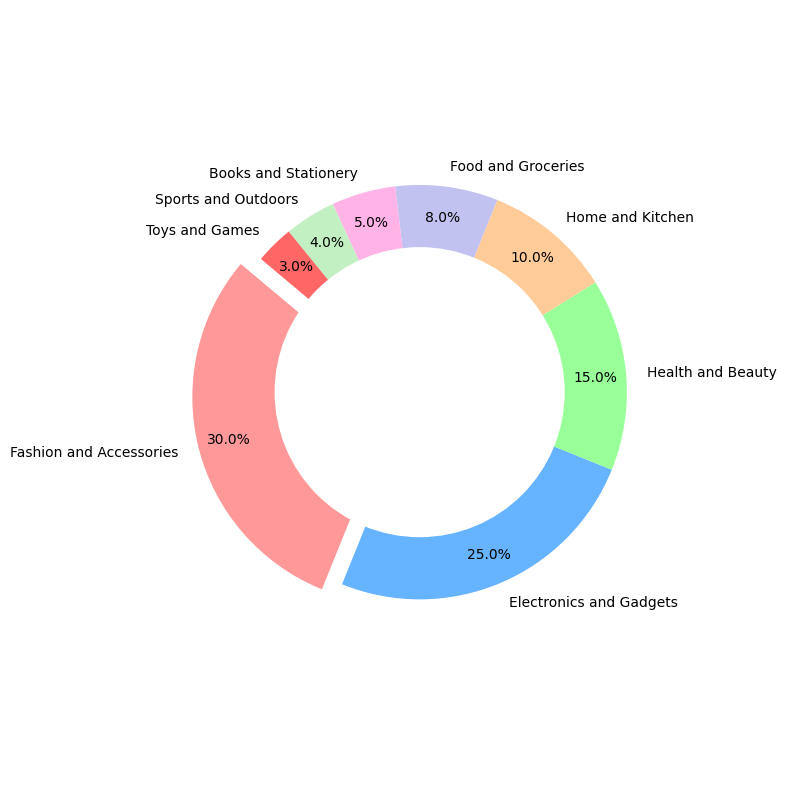which category has the highest percentage of sales? The pie chart shows that the largest wedge (30%) represents Fashion and Accessories, indicating it has the highest percentage of sales.
Answer: Fashion and Accessories What is the total percentage of Fashion and Accessories and Electronics and Gadgets combined? Fashion and Accessories has 30% and Electronics and Gadgets has 25%. Adding these two gives 30% + 25% = 55%.
Answer: 55% Which category has a smaller percentage of sales: Health and Beauty or Home and Kitchen? By comparing the wedges, Health and Beauty has 15% while Home and Kitchen has 10%. Therefore, Home and Kitchen has a smaller percentage.
Answer: Home and Kitchen How much more percentage does Fashion and Accessories have compared to Toys and Games? Fashion and Accessories has 30%, and Toys and Games has 3%. The difference is 30% - 3% = 27%.
Answer: 27% What categories together make up 50% of the sales? Adding the percentages starting from the largest: Fashion and Accessories (30%) + Electronics and Gadgets (25%) = 55%. The two categories together exceed 50%. Therefore, these two categories together make up 50%.
Answer: Fashion and Accessories and Electronics and Gadgets Which category is represented by the color red? The pie slice that has 'Fashion and Accessories' is colored differently (red) and slightly exploded from the rest. This indicates Fashion and Accessories is represented by red.
Answer: Fashion and Accessories Which two categories combined have the same percentage of sales as Electronics and Gadgets? Electronics and Gadgets has 25%. Home and Kitchen (10%) and Health and Beauty (15%) combined make 10% + 15% = 25%.
Answer: Home and Kitchen and Health and Beauty What is the percentage difference between the largest and smallest categories? The largest category is Fashion and Accessories at 30% and the smallest is Toys and Games at 3%. The difference is 30% - 3% = 27%.
Answer: 27% What percentage of sales do Food and Groceries and Books and Stationery together account for? Food and Groceries is 8% and Books and Stationery is 5%. Adding these gives 8% + 5% = 13%.
Answer: 13% How many categories have sales percentages represented with more than one color in the pie chart? The pie chart shows eight different colors representing eight categories. Therefore, only the first category, Fashion and Accessories, is visually highlighted with a different color and exploded slice.
Answer: One 